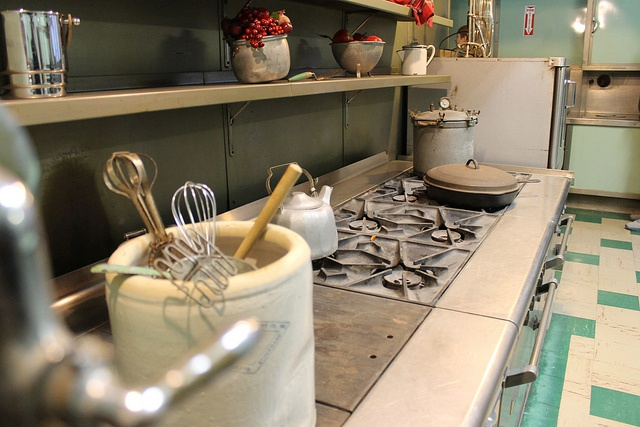Describe the objects in this image and their specific colors. I can see oven in black, tan, darkgray, and beige tones, refrigerator in black and tan tones, spoon in black, tan, and olive tones, bowl in black, gray, and maroon tones, and bottle in black, tan, maroon, gray, and olive tones in this image. 